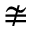<formula> <loc_0><loc_0><loc_500><loc_500>\ncong</formula> 